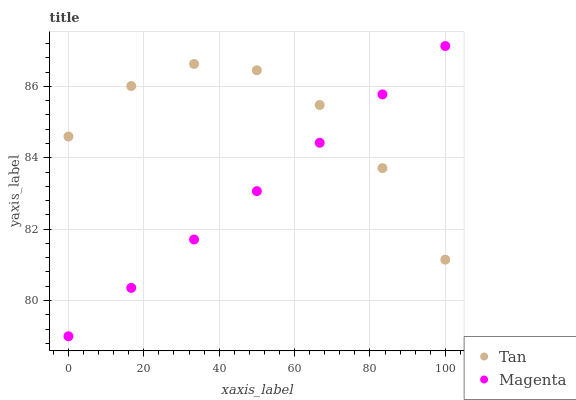Does Magenta have the minimum area under the curve?
Answer yes or no. Yes. Does Tan have the maximum area under the curve?
Answer yes or no. Yes. Does Magenta have the maximum area under the curve?
Answer yes or no. No. Is Magenta the smoothest?
Answer yes or no. Yes. Is Tan the roughest?
Answer yes or no. Yes. Is Magenta the roughest?
Answer yes or no. No. Does Magenta have the lowest value?
Answer yes or no. Yes. Does Magenta have the highest value?
Answer yes or no. Yes. Does Magenta intersect Tan?
Answer yes or no. Yes. Is Magenta less than Tan?
Answer yes or no. No. Is Magenta greater than Tan?
Answer yes or no. No. 